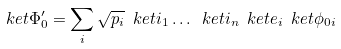<formula> <loc_0><loc_0><loc_500><loc_500>\ k e t { \Phi ^ { \prime } _ { 0 } } = \sum _ { i } \sqrt { p _ { i } } \ k e t { i _ { 1 } } \dots \ k e t { i _ { n } } \ k e t { e _ { i } } \ k e t { \phi _ { 0 i } }</formula> 